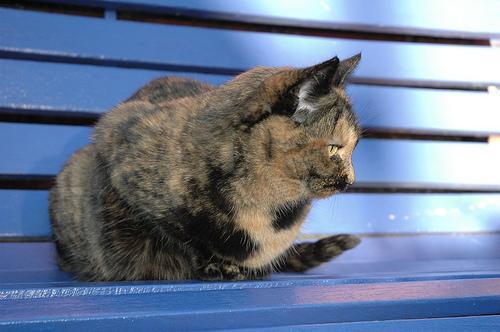How many cats are in the photo?
Give a very brief answer. 1. How many tails are on the cat's body?
Give a very brief answer. 1. 